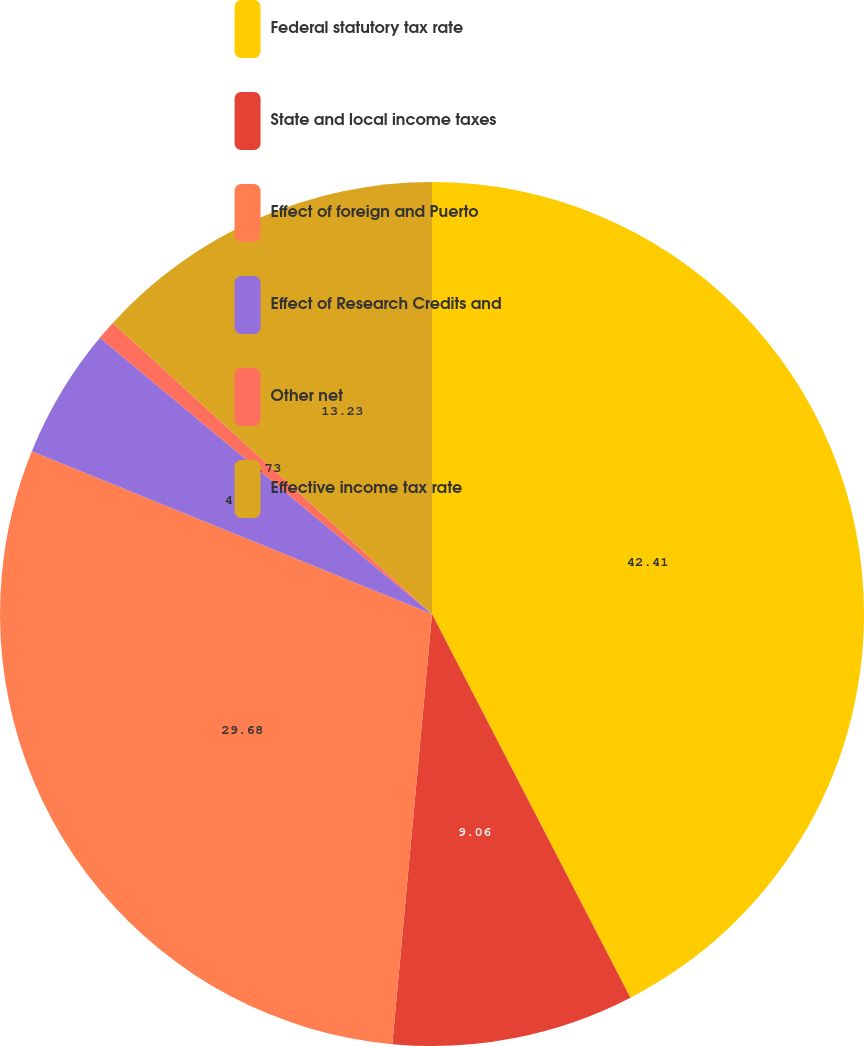Convert chart to OTSL. <chart><loc_0><loc_0><loc_500><loc_500><pie_chart><fcel>Federal statutory tax rate<fcel>State and local income taxes<fcel>Effect of foreign and Puerto<fcel>Effect of Research Credits and<fcel>Other net<fcel>Effective income tax rate<nl><fcel>42.4%<fcel>9.06%<fcel>29.68%<fcel>4.89%<fcel>0.73%<fcel>13.23%<nl></chart> 